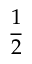Convert formula to latex. <formula><loc_0><loc_0><loc_500><loc_500>\frac { 1 } { 2 }</formula> 